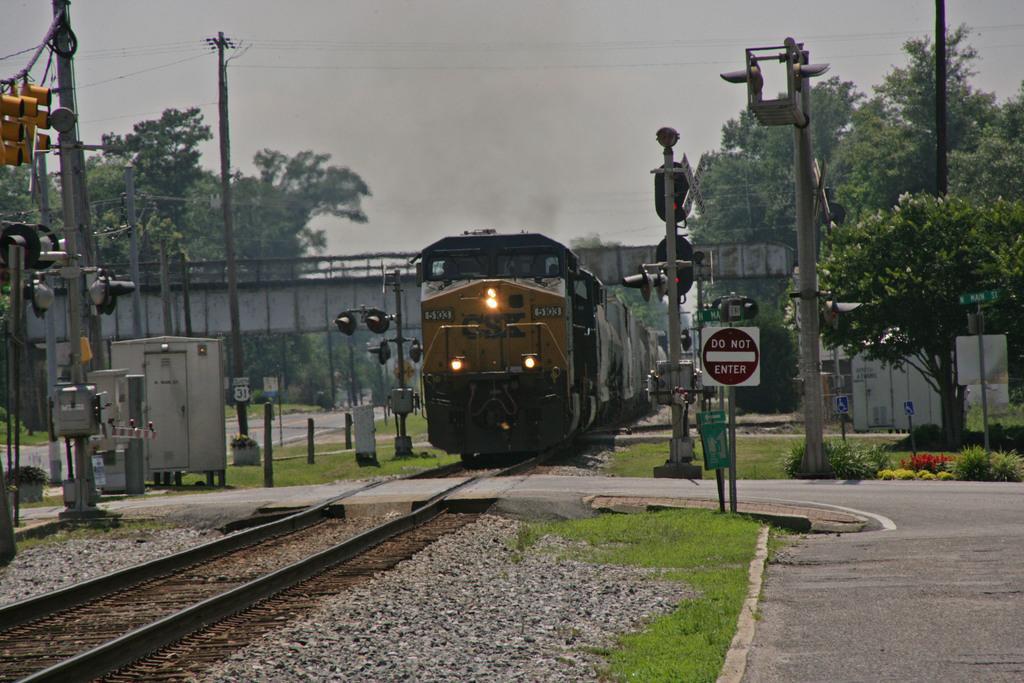In one or two sentences, can you explain what this image depicts? In this picture we can see a train on a railway track. We can see some traffic signals,wires and poles on the left side. There is a signboard on the path. We can see a few stones and some grass on the ground. Few trees are visible in the background. 